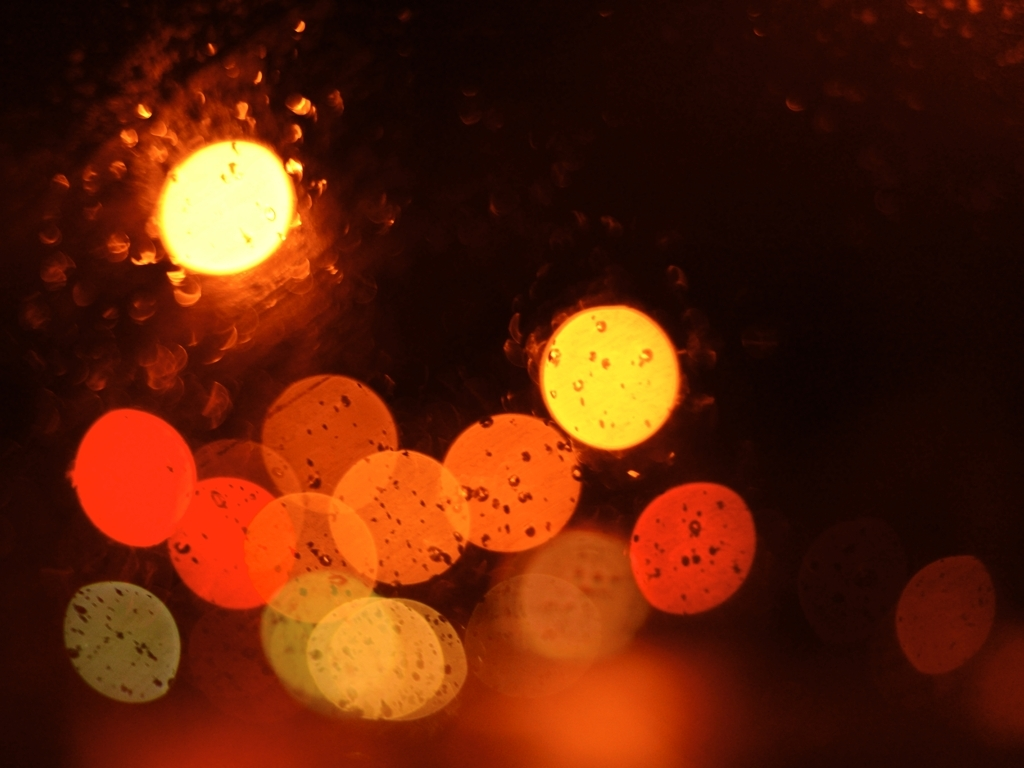What can this image represent metaphorically? Metaphorically, this image might represent the idea of perception and reality. It could suggest how our view of the world can be filtered or distorted through the 'lens' of personal experiences, emotions, or situations, similar to how the raindrops are distorting the light. 